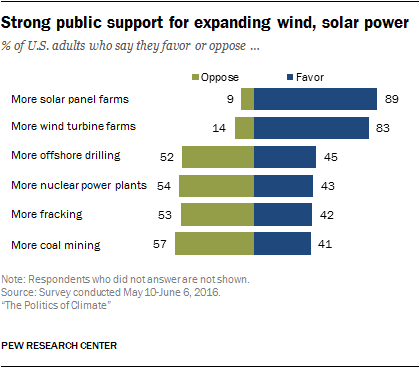Indicate a few pertinent items in this graphic. There are several options that have over 44% favoring rates, specifically three of them. According to a recent survey, 89% of people favor the establishment of more solar panel farms. 